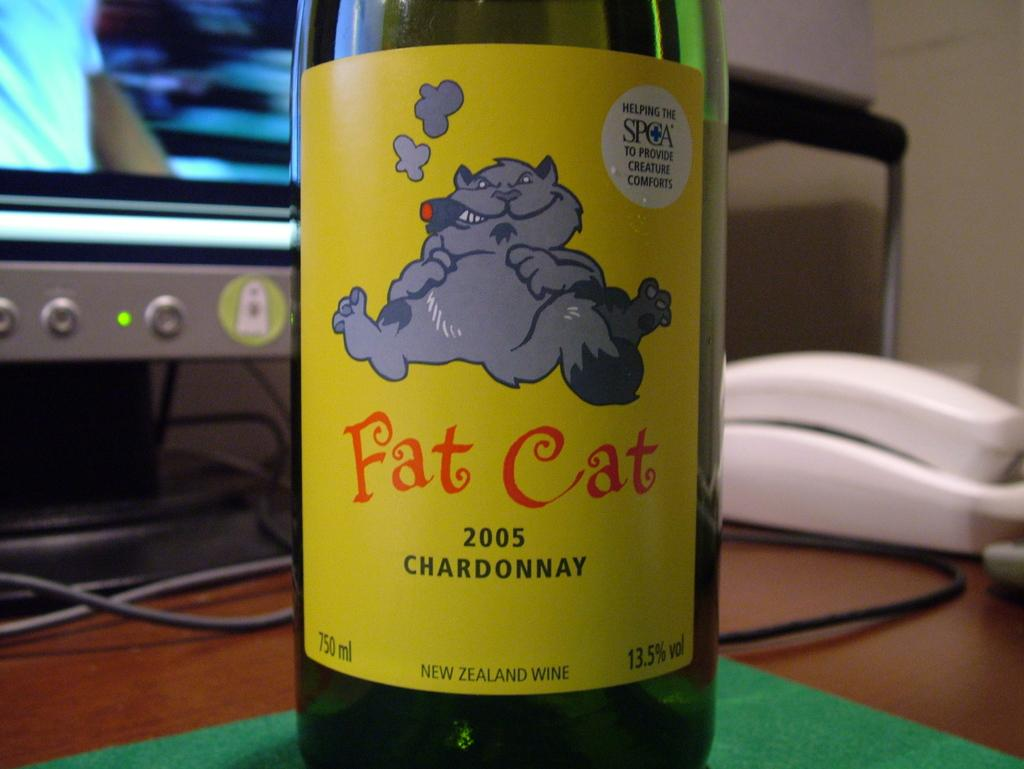<image>
Give a short and clear explanation of the subsequent image. A bottle of Fat cat Chardonnay is sitting in front of a computer monitor. 